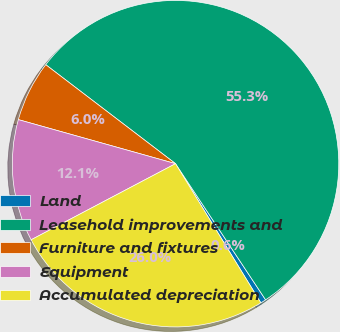Convert chart. <chart><loc_0><loc_0><loc_500><loc_500><pie_chart><fcel>Land<fcel>Leasehold improvements and<fcel>Furniture and fixtures<fcel>Equipment<fcel>Accumulated depreciation<nl><fcel>0.55%<fcel>55.33%<fcel>6.02%<fcel>12.07%<fcel>26.03%<nl></chart> 